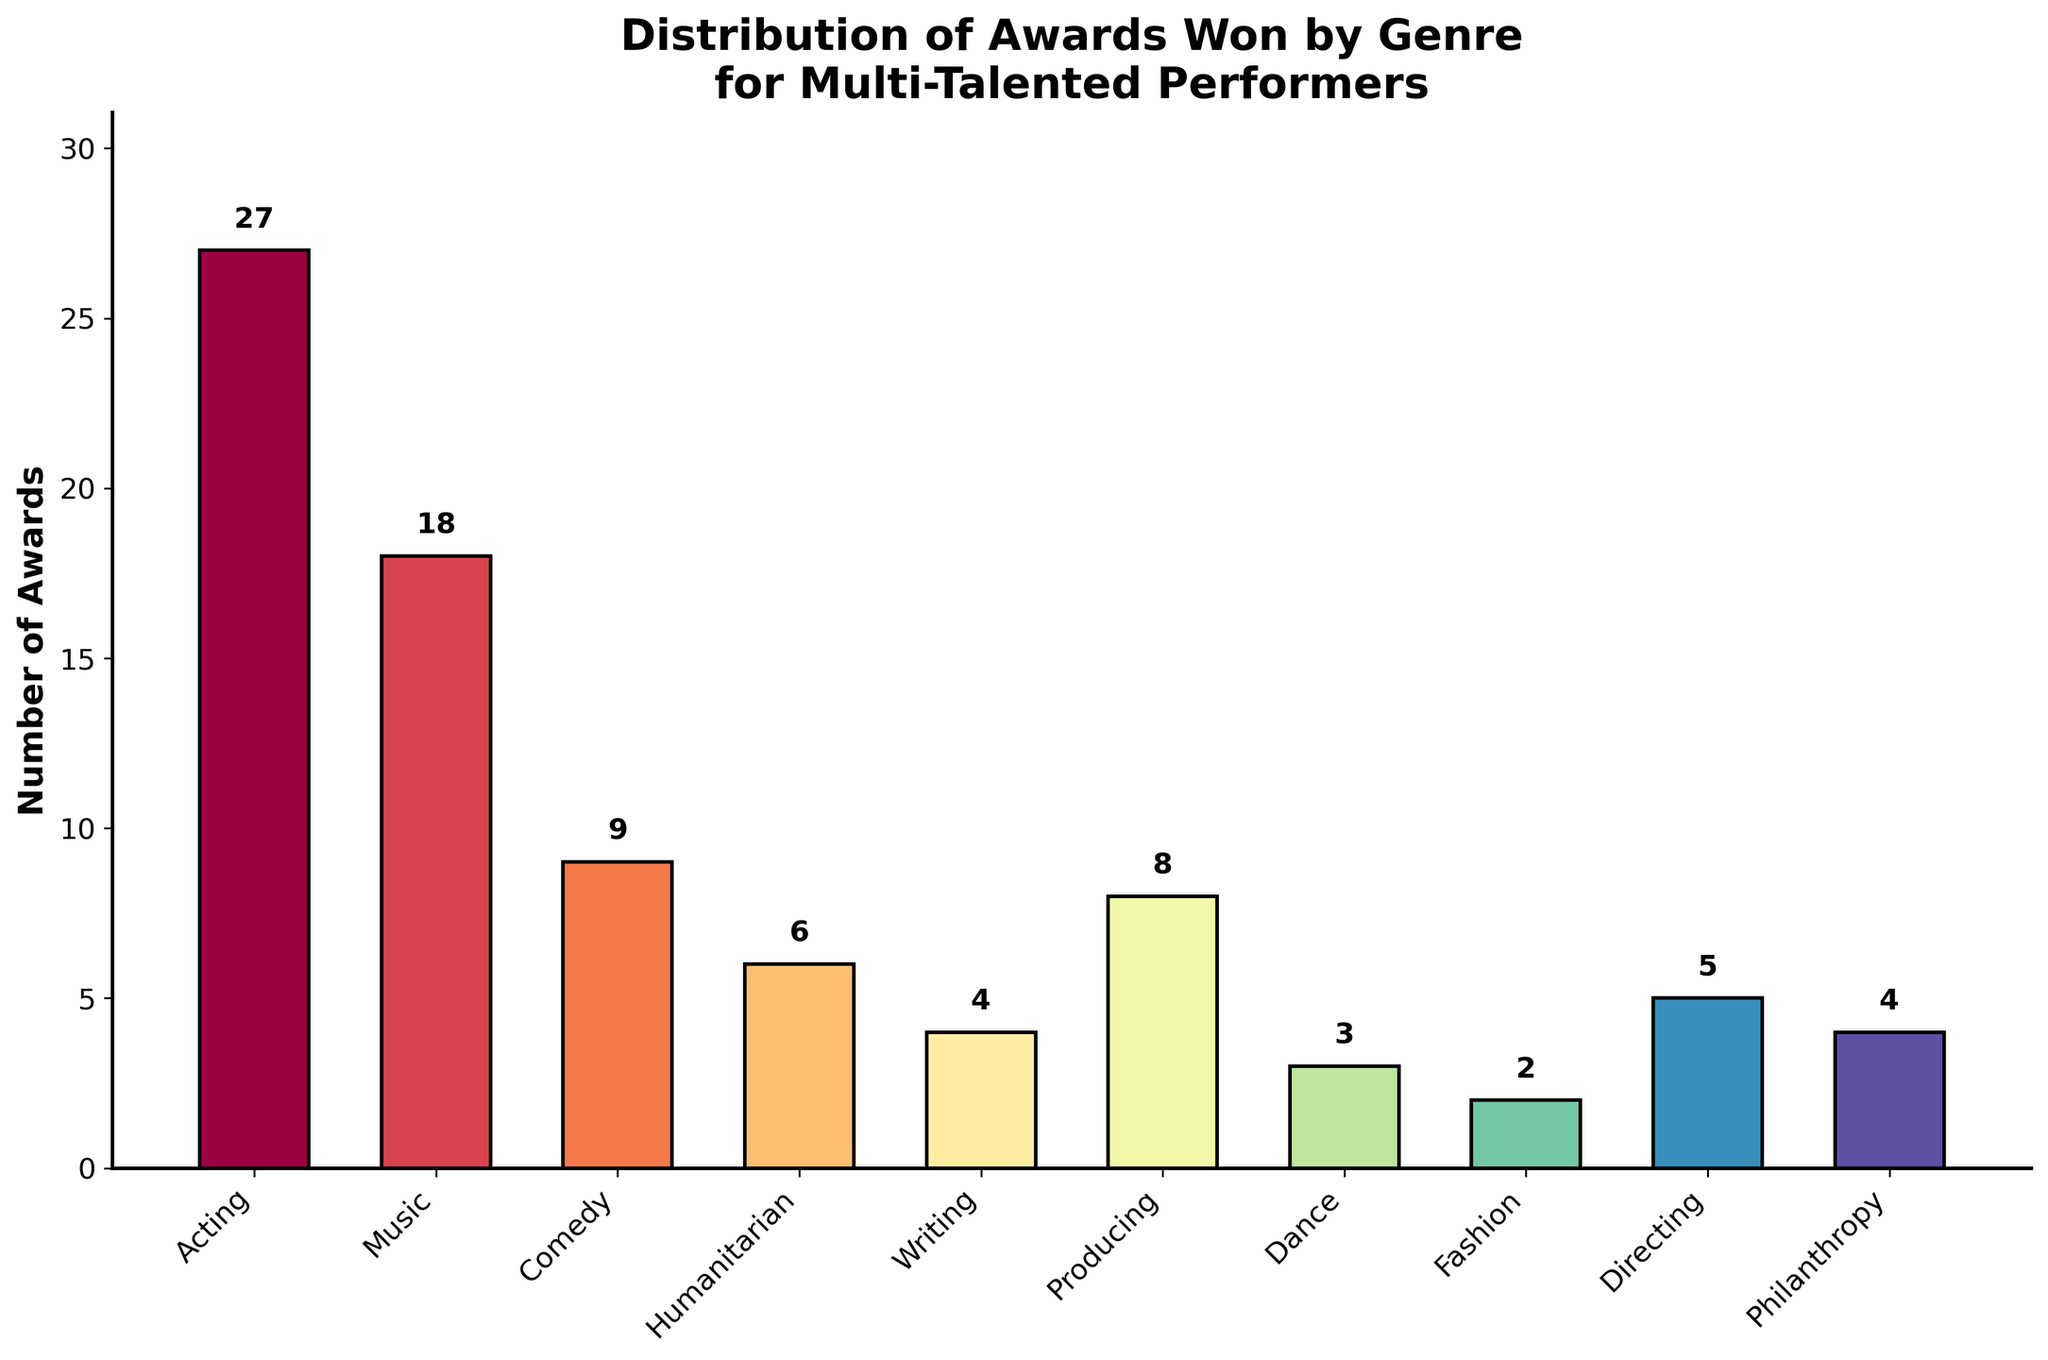Which genre has the highest number of awards? By visually inspecting the heights of the bars, the genre with the tallest bar represents the highest number of awards. In this case, Acting has the tallest bar.
Answer: Acting Which genre has the least number of awards? By visually inspecting the bar lengths, Fashion has the shortest bar, indicating the least number of awards.
Answer: Fashion How many more awards does Acting have compared to Music? Acting has 27 awards, and Music has 18 awards. Subtract Music’s awards from Acting’s awards: 27 - 18.
Answer: 9 What is the total number of awards won across all genres? Sum the values of all the awards: 27 + 18 + 9 + 6 + 4 + 8 + 3 + 2 + 5 + 4.
Answer: 86 What is the average number of awards won per genre? Sum the number of awards won across all genres: 27 + 18 + 9 + 6 + 4 + 8 + 3 + 2 + 5 + 4 = 86 and divide by the number of genres, which is 10. 86 ÷ 10.
Answer: 8.6 Which two genres combined have the same number of awards as Acting alone? Acting has 27 awards. Combining Music (18) and Comedy (9) gives us: 18 + 9 = 27.
Answer: Music and Comedy By how much do the awards for Producing exceed those for Dance? Producing has 8 awards and Dance has 3. Subtract Dance’s awards from Producing’s: 8 - 3.
Answer: 5 Which genres have won exactly 4 awards? By visually inspecting the bars and reading the labels, Writing and Philanthropy each have exactly 4 awards.
Answer: Writing and Philanthropy How many more awards does Fashion need to equal Humanitarian? Fashion has 2 awards, and Humanitarian has 6 awards. Subtract Fashion’s awards from Humanitarian’s: 6 - 2.
Answer: 4 Which genre with less than 5 awards has the most awards? By visually inspecting the genres that have bars shorter than the height of the bar for 5 awards, Directing has the most with 5 awards.
Answer: Directing 